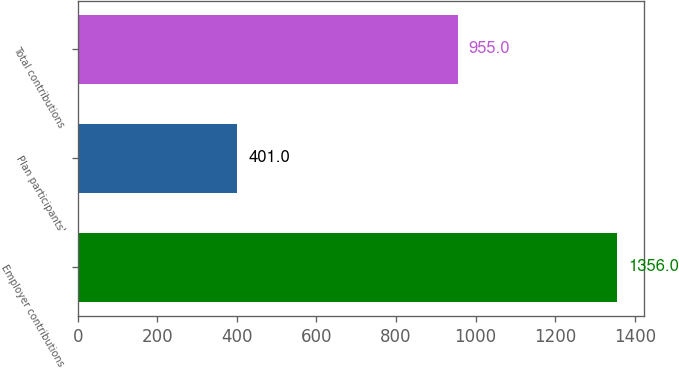<chart> <loc_0><loc_0><loc_500><loc_500><bar_chart><fcel>Employer contributions<fcel>Plan participants'<fcel>Total contributions<nl><fcel>1356<fcel>401<fcel>955<nl></chart> 